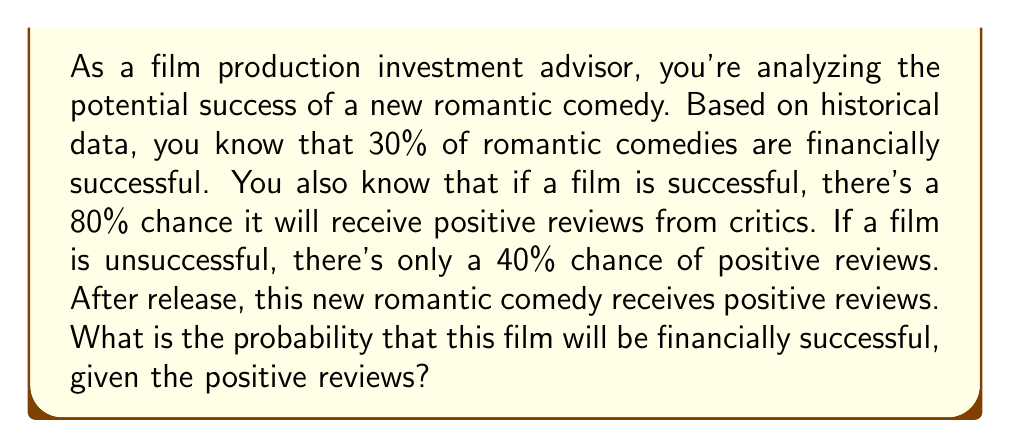Provide a solution to this math problem. To solve this problem, we'll use Bayes' theorem, which is fundamental in Bayesian inference. Let's define our events:

A: The film is financially successful
B: The film receives positive reviews

We're given the following probabilities:

P(A) = 0.30 (prior probability of success)
P(B|A) = 0.80 (probability of positive reviews given success)
P(B|not A) = 0.40 (probability of positive reviews given failure)

We want to find P(A|B), the probability of success given positive reviews.

Bayes' theorem states:

$$P(A|B) = \frac{P(B|A) \cdot P(A)}{P(B)}$$

We need to calculate P(B), which we can do using the law of total probability:

$$P(B) = P(B|A) \cdot P(A) + P(B|\text{not }A) \cdot P(\text{not }A)$$

$$P(B) = 0.80 \cdot 0.30 + 0.40 \cdot 0.70 = 0.24 + 0.28 = 0.52$$

Now we can apply Bayes' theorem:

$$P(A|B) = \frac{0.80 \cdot 0.30}{0.52} = \frac{0.24}{0.52} \approx 0.4615$$
Answer: The probability that the film will be financially successful, given the positive reviews, is approximately 0.4615 or 46.15%. 